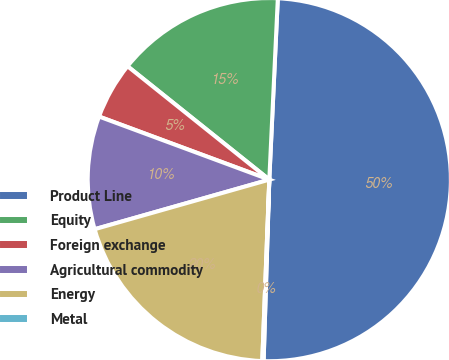Convert chart. <chart><loc_0><loc_0><loc_500><loc_500><pie_chart><fcel>Product Line<fcel>Equity<fcel>Foreign exchange<fcel>Agricultural commodity<fcel>Energy<fcel>Metal<nl><fcel>49.75%<fcel>15.01%<fcel>5.09%<fcel>10.05%<fcel>19.98%<fcel>0.12%<nl></chart> 